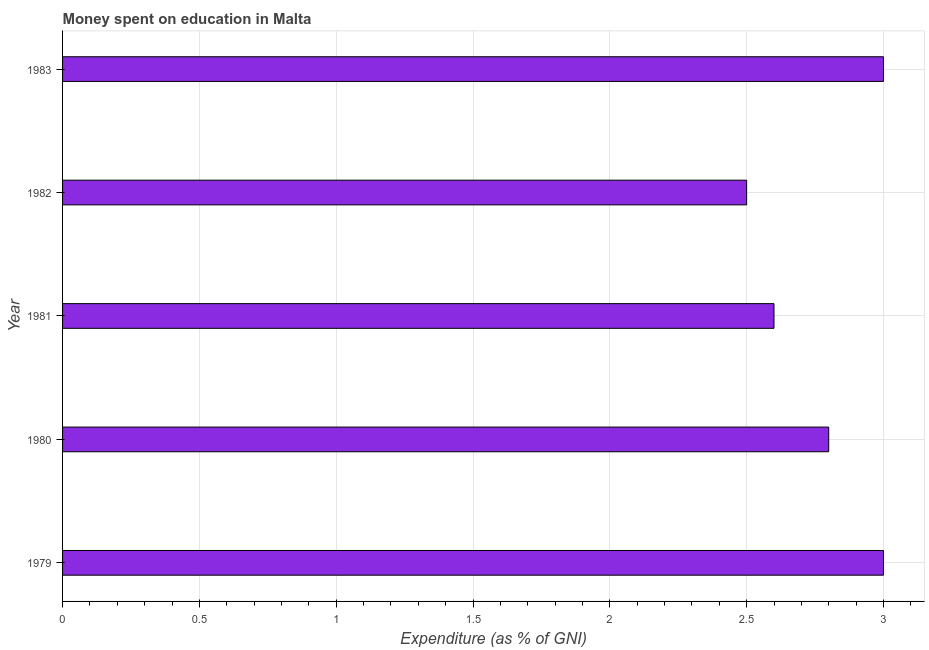Does the graph contain any zero values?
Provide a succinct answer. No. What is the title of the graph?
Offer a terse response. Money spent on education in Malta. What is the label or title of the X-axis?
Provide a short and direct response. Expenditure (as % of GNI). What is the expenditure on education in 1980?
Provide a short and direct response. 2.8. Across all years, what is the maximum expenditure on education?
Offer a very short reply. 3. Across all years, what is the minimum expenditure on education?
Ensure brevity in your answer.  2.5. In which year was the expenditure on education maximum?
Offer a terse response. 1979. What is the sum of the expenditure on education?
Ensure brevity in your answer.  13.9. What is the difference between the expenditure on education in 1979 and 1983?
Ensure brevity in your answer.  0. What is the average expenditure on education per year?
Offer a terse response. 2.78. What is the median expenditure on education?
Offer a very short reply. 2.8. Do a majority of the years between 1980 and 1979 (inclusive) have expenditure on education greater than 0.2 %?
Your response must be concise. No. What is the ratio of the expenditure on education in 1980 to that in 1982?
Your answer should be compact. 1.12. What is the difference between the highest and the lowest expenditure on education?
Give a very brief answer. 0.5. How many bars are there?
Give a very brief answer. 5. Are all the bars in the graph horizontal?
Provide a succinct answer. Yes. How many years are there in the graph?
Offer a terse response. 5. What is the difference between two consecutive major ticks on the X-axis?
Keep it short and to the point. 0.5. What is the Expenditure (as % of GNI) of 1979?
Make the answer very short. 3. What is the Expenditure (as % of GNI) of 1980?
Give a very brief answer. 2.8. What is the Expenditure (as % of GNI) of 1982?
Make the answer very short. 2.5. What is the Expenditure (as % of GNI) in 1983?
Keep it short and to the point. 3. What is the difference between the Expenditure (as % of GNI) in 1979 and 1980?
Offer a very short reply. 0.2. What is the difference between the Expenditure (as % of GNI) in 1979 and 1981?
Provide a succinct answer. 0.4. What is the difference between the Expenditure (as % of GNI) in 1980 and 1982?
Give a very brief answer. 0.3. What is the difference between the Expenditure (as % of GNI) in 1981 and 1982?
Make the answer very short. 0.1. What is the difference between the Expenditure (as % of GNI) in 1982 and 1983?
Give a very brief answer. -0.5. What is the ratio of the Expenditure (as % of GNI) in 1979 to that in 1980?
Your answer should be compact. 1.07. What is the ratio of the Expenditure (as % of GNI) in 1979 to that in 1981?
Provide a succinct answer. 1.15. What is the ratio of the Expenditure (as % of GNI) in 1979 to that in 1983?
Give a very brief answer. 1. What is the ratio of the Expenditure (as % of GNI) in 1980 to that in 1981?
Your response must be concise. 1.08. What is the ratio of the Expenditure (as % of GNI) in 1980 to that in 1982?
Give a very brief answer. 1.12. What is the ratio of the Expenditure (as % of GNI) in 1980 to that in 1983?
Offer a terse response. 0.93. What is the ratio of the Expenditure (as % of GNI) in 1981 to that in 1982?
Ensure brevity in your answer.  1.04. What is the ratio of the Expenditure (as % of GNI) in 1981 to that in 1983?
Offer a very short reply. 0.87. What is the ratio of the Expenditure (as % of GNI) in 1982 to that in 1983?
Provide a short and direct response. 0.83. 